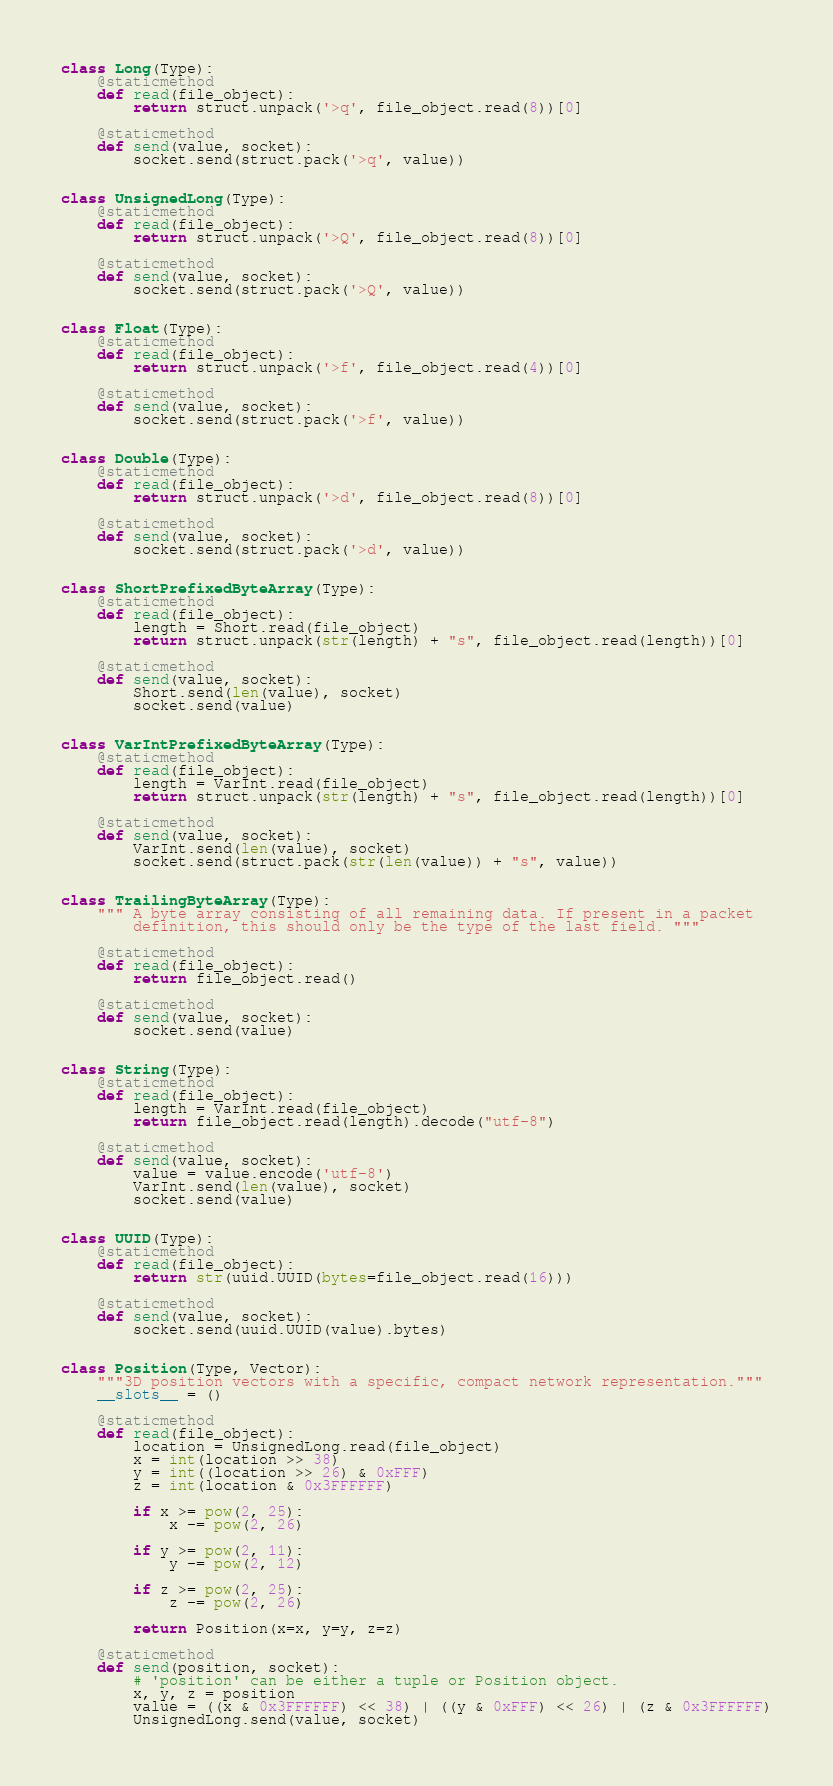Convert code to text. <code><loc_0><loc_0><loc_500><loc_500><_Python_>

class Long(Type):
    @staticmethod
    def read(file_object):
        return struct.unpack('>q', file_object.read(8))[0]

    @staticmethod
    def send(value, socket):
        socket.send(struct.pack('>q', value))


class UnsignedLong(Type):
    @staticmethod
    def read(file_object):
        return struct.unpack('>Q', file_object.read(8))[0]

    @staticmethod
    def send(value, socket):
        socket.send(struct.pack('>Q', value))


class Float(Type):
    @staticmethod
    def read(file_object):
        return struct.unpack('>f', file_object.read(4))[0]

    @staticmethod
    def send(value, socket):
        socket.send(struct.pack('>f', value))


class Double(Type):
    @staticmethod
    def read(file_object):
        return struct.unpack('>d', file_object.read(8))[0]

    @staticmethod
    def send(value, socket):
        socket.send(struct.pack('>d', value))


class ShortPrefixedByteArray(Type):
    @staticmethod
    def read(file_object):
        length = Short.read(file_object)
        return struct.unpack(str(length) + "s", file_object.read(length))[0]

    @staticmethod
    def send(value, socket):
        Short.send(len(value), socket)
        socket.send(value)


class VarIntPrefixedByteArray(Type):
    @staticmethod
    def read(file_object):
        length = VarInt.read(file_object)
        return struct.unpack(str(length) + "s", file_object.read(length))[0]

    @staticmethod
    def send(value, socket):
        VarInt.send(len(value), socket)
        socket.send(struct.pack(str(len(value)) + "s", value))


class TrailingByteArray(Type):
    """ A byte array consisting of all remaining data. If present in a packet
        definition, this should only be the type of the last field. """

    @staticmethod
    def read(file_object):
        return file_object.read()

    @staticmethod
    def send(value, socket):
        socket.send(value)


class String(Type):
    @staticmethod
    def read(file_object):
        length = VarInt.read(file_object)
        return file_object.read(length).decode("utf-8")

    @staticmethod
    def send(value, socket):
        value = value.encode('utf-8')
        VarInt.send(len(value), socket)
        socket.send(value)


class UUID(Type):
    @staticmethod
    def read(file_object):
        return str(uuid.UUID(bytes=file_object.read(16)))

    @staticmethod
    def send(value, socket):
        socket.send(uuid.UUID(value).bytes)


class Position(Type, Vector):
    """3D position vectors with a specific, compact network representation."""
    __slots__ = ()

    @staticmethod
    def read(file_object):
        location = UnsignedLong.read(file_object)
        x = int(location >> 38)
        y = int((location >> 26) & 0xFFF)
        z = int(location & 0x3FFFFFF)

        if x >= pow(2, 25):
            x -= pow(2, 26)

        if y >= pow(2, 11):
            y -= pow(2, 12)

        if z >= pow(2, 25):
            z -= pow(2, 26)

        return Position(x=x, y=y, z=z)

    @staticmethod
    def send(position, socket):
        # 'position' can be either a tuple or Position object.
        x, y, z = position
        value = ((x & 0x3FFFFFF) << 38) | ((y & 0xFFF) << 26) | (z & 0x3FFFFFF)
        UnsignedLong.send(value, socket)
</code> 